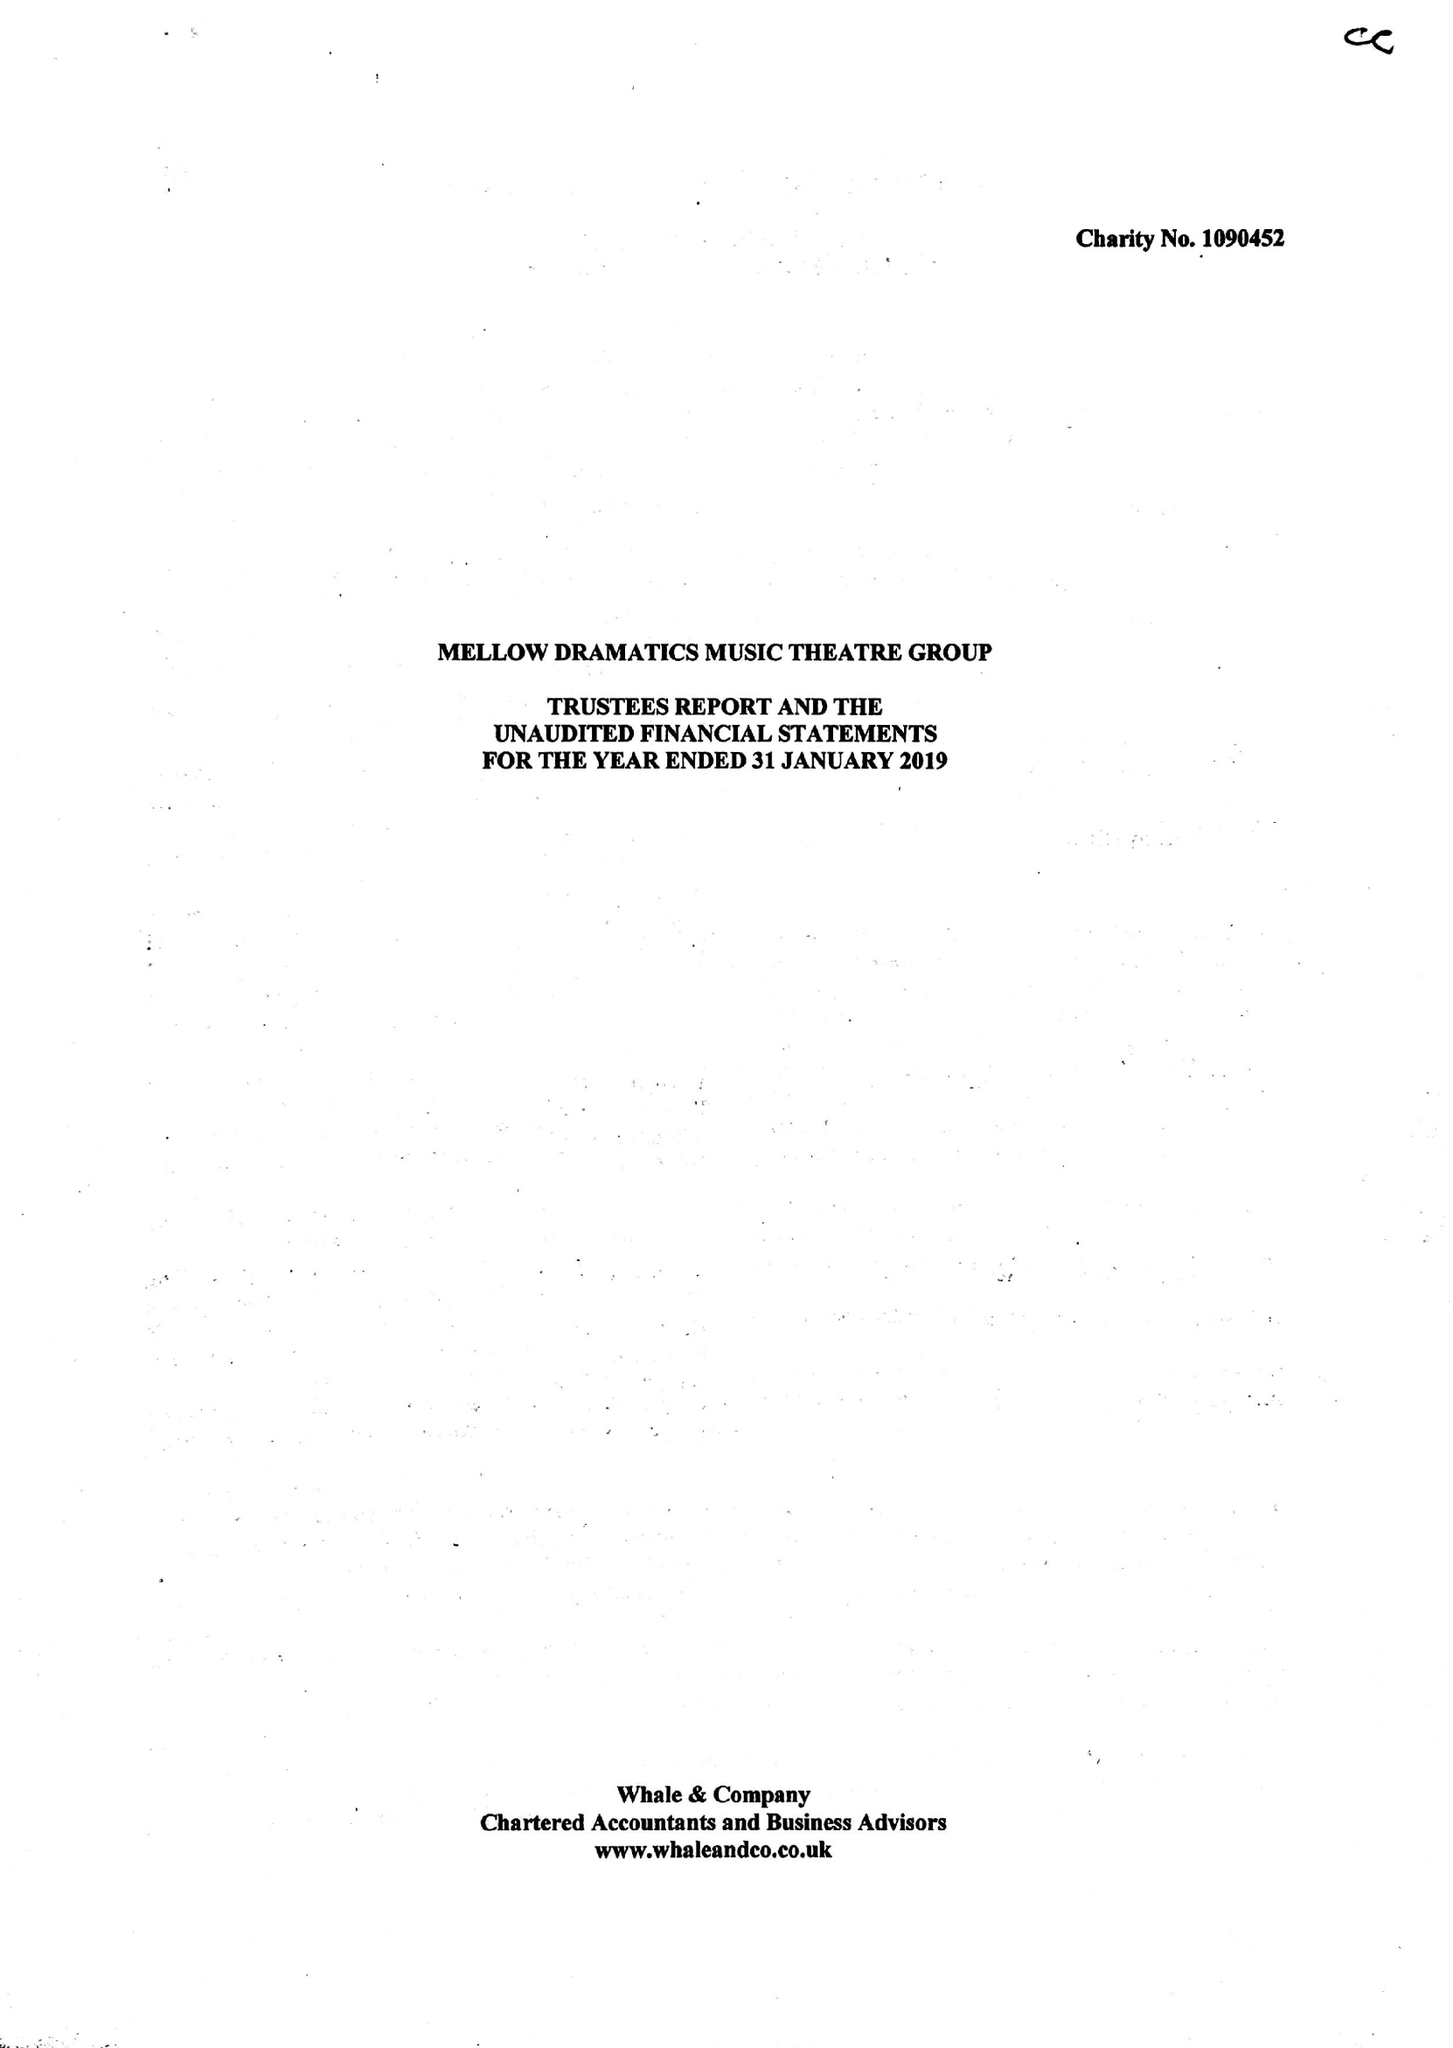What is the value for the address__postcode?
Answer the question using a single word or phrase. DE15 9GS 